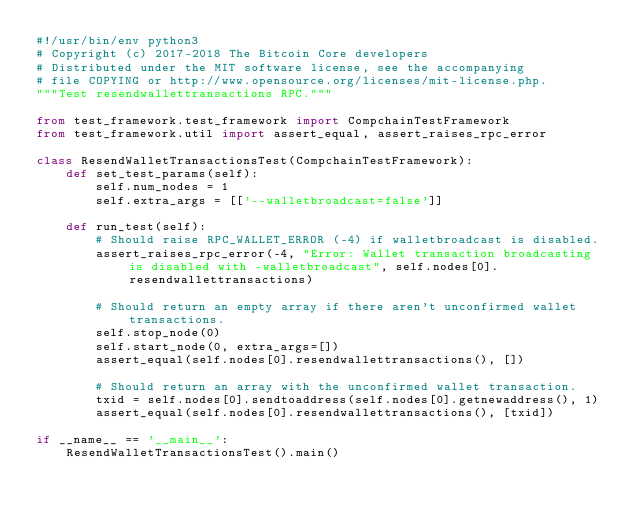<code> <loc_0><loc_0><loc_500><loc_500><_Python_>#!/usr/bin/env python3
# Copyright (c) 2017-2018 The Bitcoin Core developers
# Distributed under the MIT software license, see the accompanying
# file COPYING or http://www.opensource.org/licenses/mit-license.php.
"""Test resendwallettransactions RPC."""

from test_framework.test_framework import CompchainTestFramework
from test_framework.util import assert_equal, assert_raises_rpc_error

class ResendWalletTransactionsTest(CompchainTestFramework):
    def set_test_params(self):
        self.num_nodes = 1
        self.extra_args = [['--walletbroadcast=false']]

    def run_test(self):
        # Should raise RPC_WALLET_ERROR (-4) if walletbroadcast is disabled.
        assert_raises_rpc_error(-4, "Error: Wallet transaction broadcasting is disabled with -walletbroadcast", self.nodes[0].resendwallettransactions)

        # Should return an empty array if there aren't unconfirmed wallet transactions.
        self.stop_node(0)
        self.start_node(0, extra_args=[])
        assert_equal(self.nodes[0].resendwallettransactions(), [])

        # Should return an array with the unconfirmed wallet transaction.
        txid = self.nodes[0].sendtoaddress(self.nodes[0].getnewaddress(), 1)
        assert_equal(self.nodes[0].resendwallettransactions(), [txid])

if __name__ == '__main__':
    ResendWalletTransactionsTest().main()
</code> 